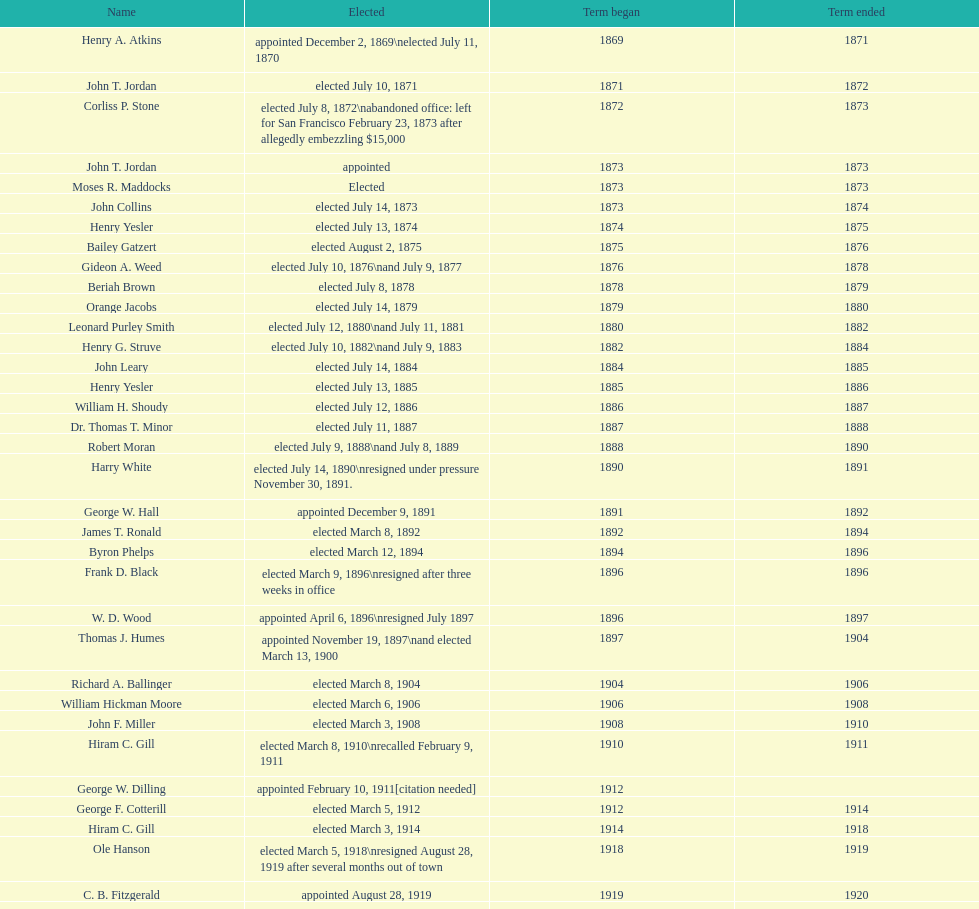During 1871, who was the only one that managed to get elected? John T. Jordan. 